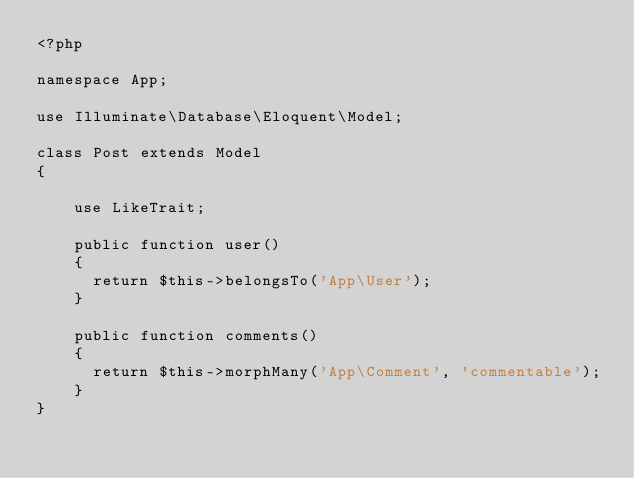<code> <loc_0><loc_0><loc_500><loc_500><_PHP_><?php

namespace App;

use Illuminate\Database\Eloquent\Model;

class Post extends Model
{

    use LikeTrait;

    public function user()
    {
      return $this->belongsTo('App\User');
    }

    public function comments()
    {
      return $this->morphMany('App\Comment', 'commentable');
    }
}
</code> 